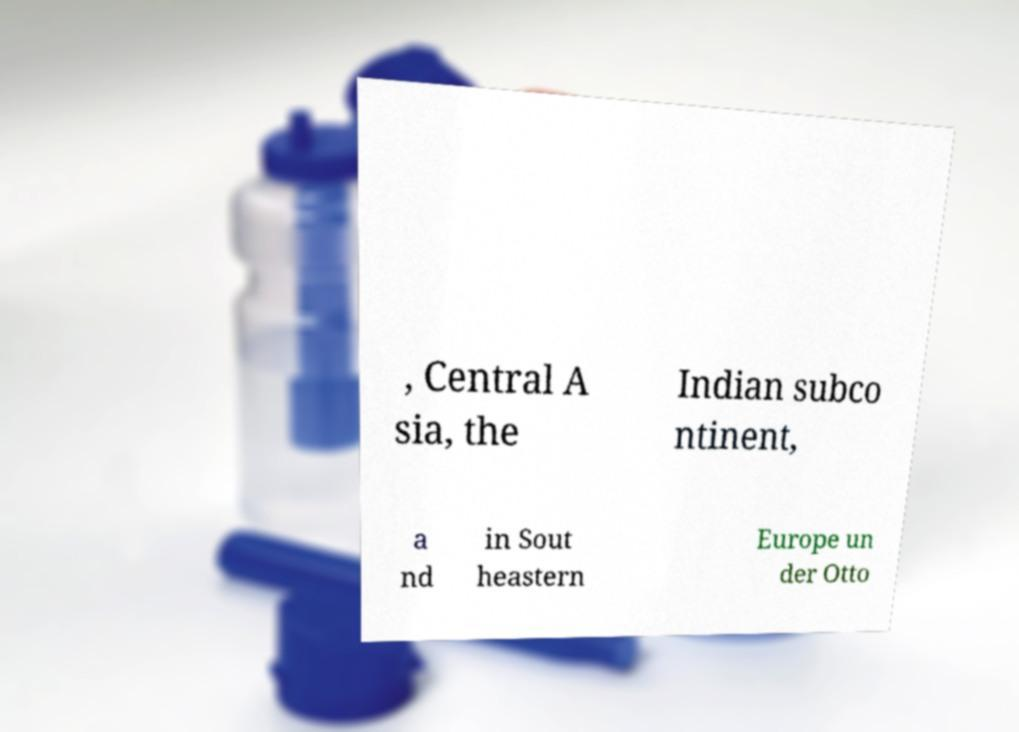I need the written content from this picture converted into text. Can you do that? , Central A sia, the Indian subco ntinent, a nd in Sout heastern Europe un der Otto 